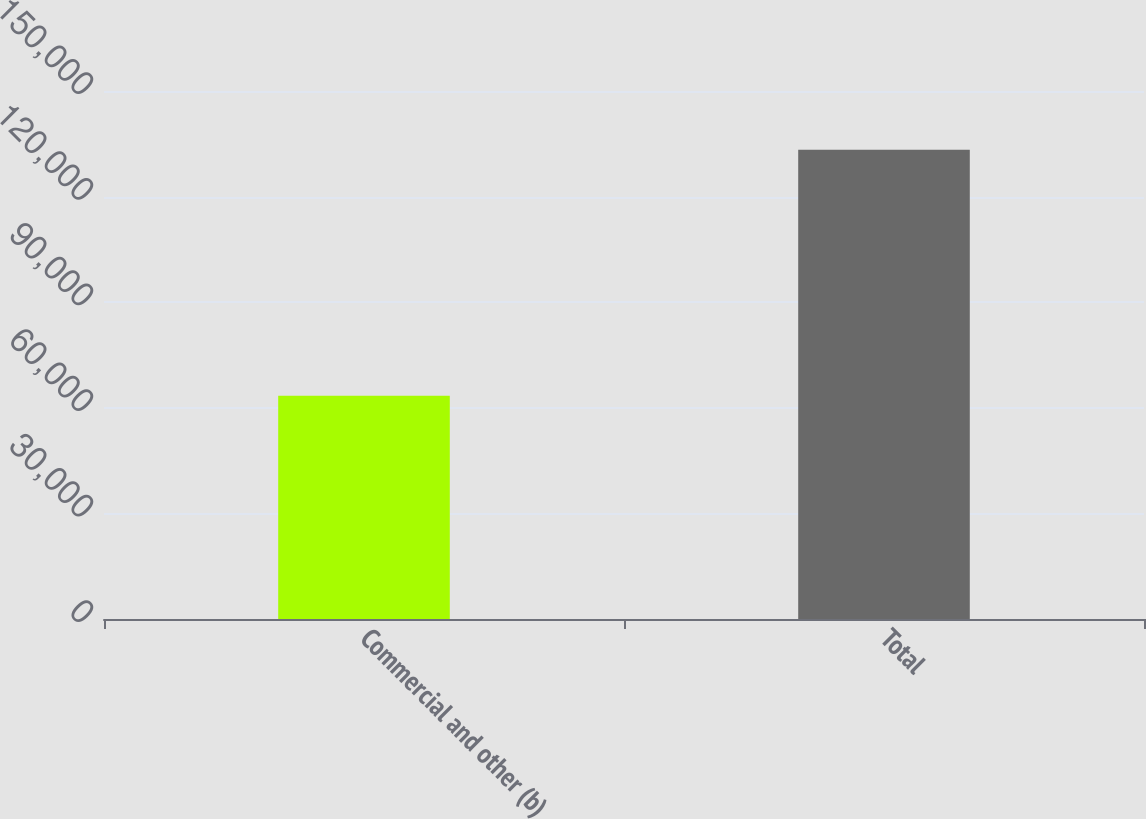Convert chart to OTSL. <chart><loc_0><loc_0><loc_500><loc_500><bar_chart><fcel>Commercial and other (b)<fcel>Total<nl><fcel>63411<fcel>133303<nl></chart> 